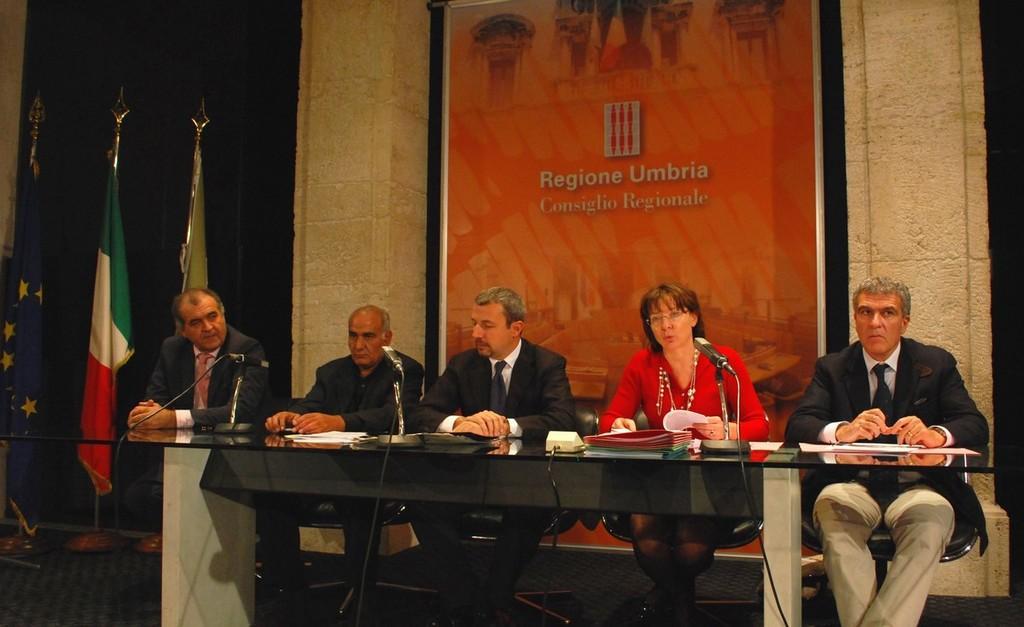Can you describe this image briefly? In this image I can see few people are sitting on the chairs in front of the table. On the table there are few papers are placed. In the background there is a wall and one banner is hanging to the wall. On the left side of the image there are three flags. 